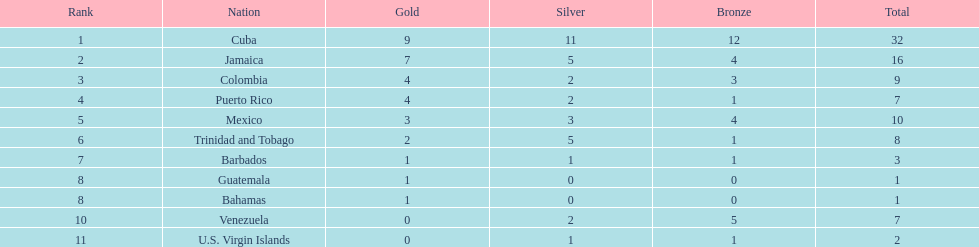Number of teams above 9 medals 3. 